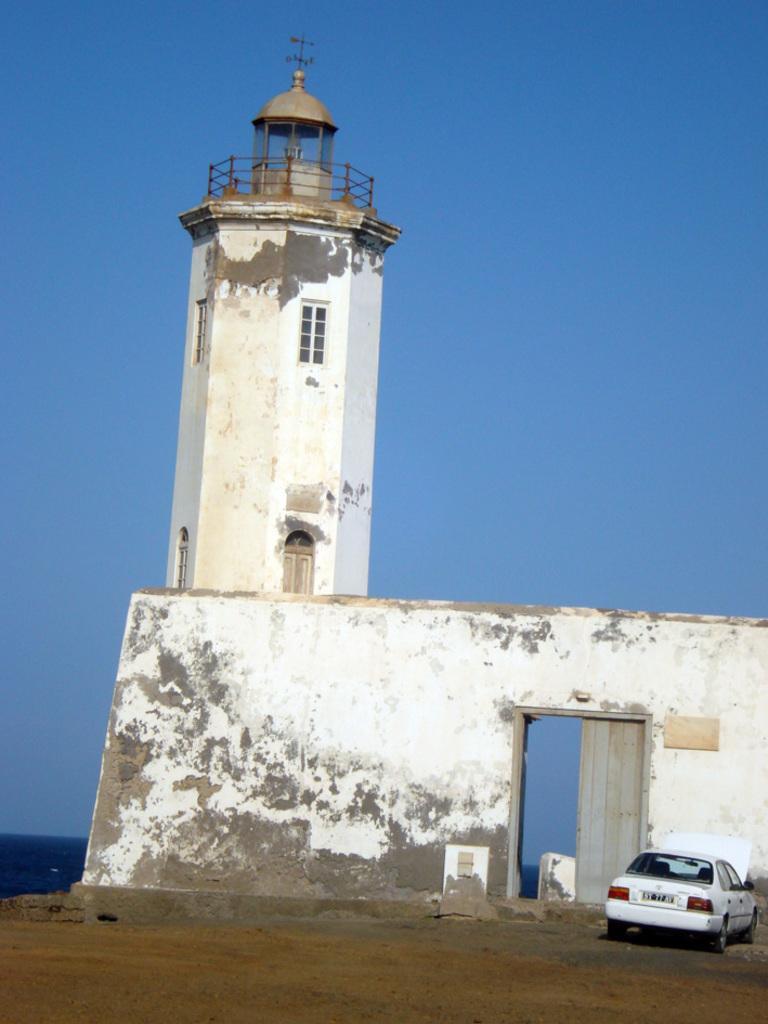Could you give a brief overview of what you see in this image? In this image I can see the car on the ground. The car is in white color. In-front of the car I can see the wall and the tower. In the background I can see the blue sky. 